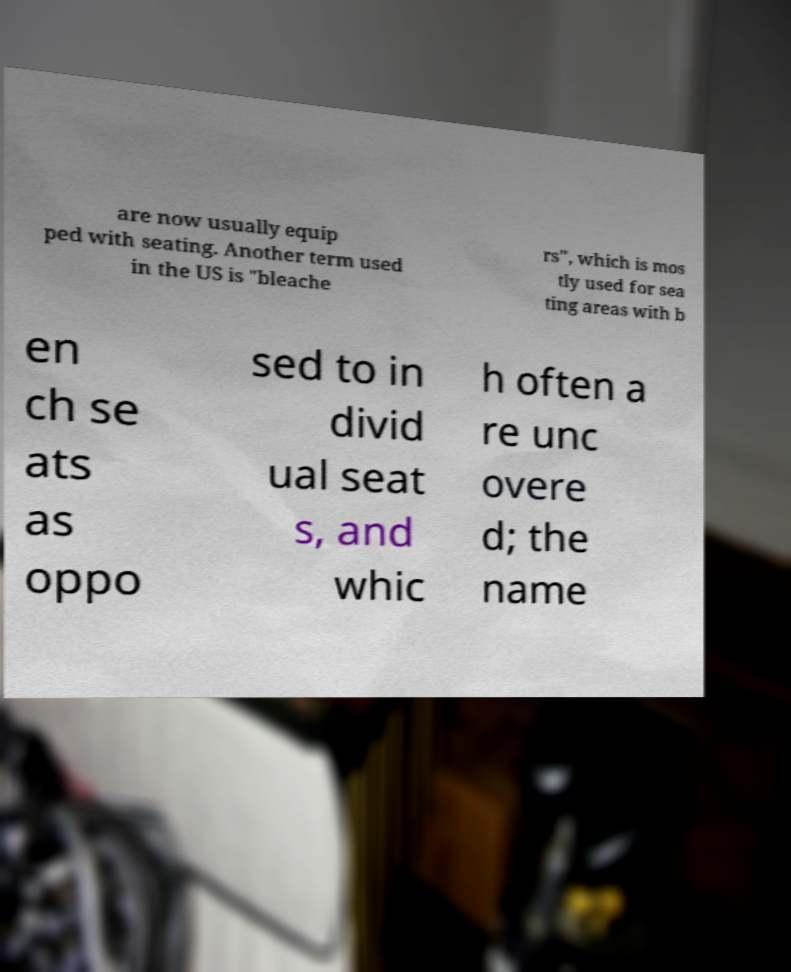Please read and relay the text visible in this image. What does it say? are now usually equip ped with seating. Another term used in the US is "bleache rs", which is mos tly used for sea ting areas with b en ch se ats as oppo sed to in divid ual seat s, and whic h often a re unc overe d; the name 